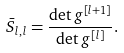Convert formula to latex. <formula><loc_0><loc_0><loc_500><loc_500>\bar { S } _ { l , l } = \frac { \det g ^ { [ l + 1 ] } } { \det g ^ { [ l ] } } .</formula> 